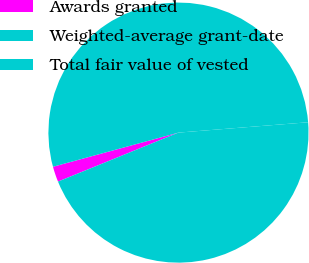Convert chart to OTSL. <chart><loc_0><loc_0><loc_500><loc_500><pie_chart><fcel>Awards granted<fcel>Weighted-average grant-date<fcel>Total fair value of vested<nl><fcel>1.92%<fcel>52.96%<fcel>45.12%<nl></chart> 